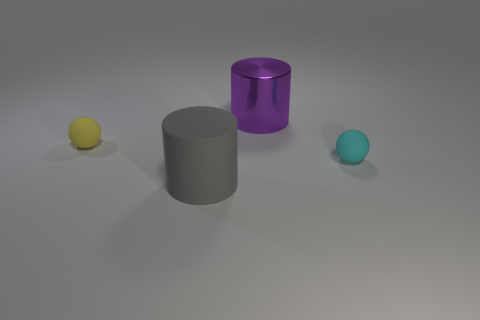Add 3 big gray rubber things. How many objects exist? 7 Subtract 0 green balls. How many objects are left? 4 Subtract all gray balls. Subtract all green cylinders. How many balls are left? 2 Subtract all gray things. Subtract all tiny cyan rubber spheres. How many objects are left? 2 Add 4 big cylinders. How many big cylinders are left? 6 Add 3 large gray matte objects. How many large gray matte objects exist? 4 